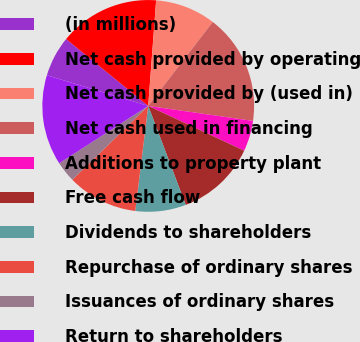Convert chart to OTSL. <chart><loc_0><loc_0><loc_500><loc_500><pie_chart><fcel>(in millions)<fcel>Net cash provided by operating<fcel>Net cash provided by (used in)<fcel>Net cash used in financing<fcel>Additions to property plant<fcel>Free cash flow<fcel>Dividends to shareholders<fcel>Repurchase of ordinary shares<fcel>Issuances of ordinary shares<fcel>Return to shareholders<nl><fcel>6.21%<fcel>15.31%<fcel>9.24%<fcel>16.83%<fcel>4.69%<fcel>12.28%<fcel>7.72%<fcel>10.76%<fcel>3.17%<fcel>13.79%<nl></chart> 